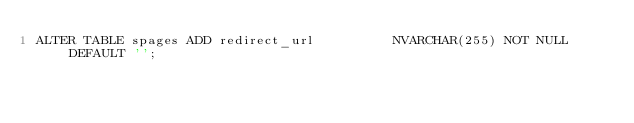Convert code to text. <code><loc_0><loc_0><loc_500><loc_500><_SQL_>ALTER TABLE spages ADD redirect_url          NVARCHAR(255) NOT NULL DEFAULT '';
</code> 